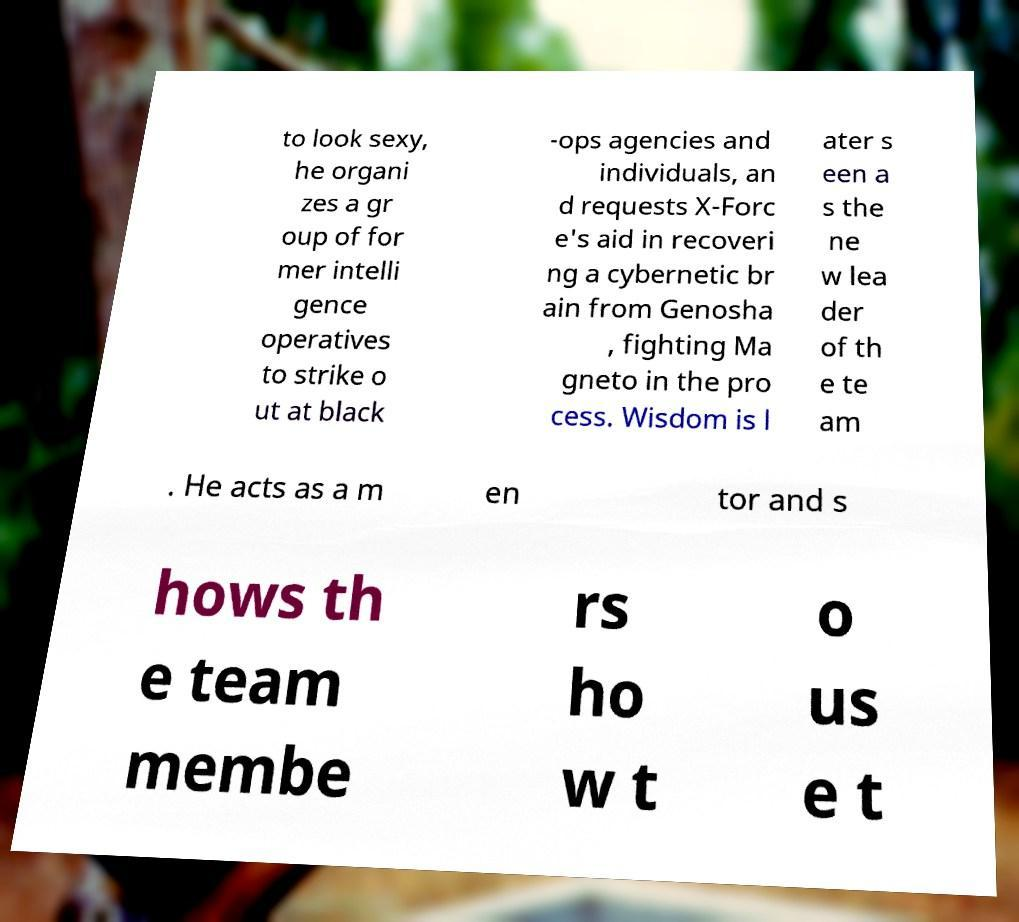There's text embedded in this image that I need extracted. Can you transcribe it verbatim? to look sexy, he organi zes a gr oup of for mer intelli gence operatives to strike o ut at black -ops agencies and individuals, an d requests X-Forc e's aid in recoveri ng a cybernetic br ain from Genosha , fighting Ma gneto in the pro cess. Wisdom is l ater s een a s the ne w lea der of th e te am . He acts as a m en tor and s hows th e team membe rs ho w t o us e t 